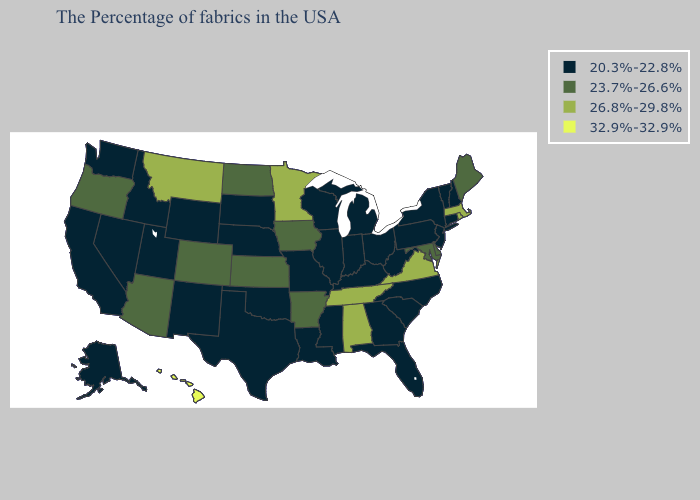What is the lowest value in the USA?
Be succinct. 20.3%-22.8%. Name the states that have a value in the range 26.8%-29.8%?
Be succinct. Massachusetts, Rhode Island, Virginia, Alabama, Tennessee, Minnesota, Montana. Among the states that border Arizona , which have the lowest value?
Quick response, please. New Mexico, Utah, Nevada, California. Among the states that border Idaho , does Montana have the highest value?
Quick response, please. Yes. Which states hav the highest value in the Northeast?
Quick response, please. Massachusetts, Rhode Island. Name the states that have a value in the range 23.7%-26.6%?
Be succinct. Maine, Delaware, Maryland, Arkansas, Iowa, Kansas, North Dakota, Colorado, Arizona, Oregon. Name the states that have a value in the range 23.7%-26.6%?
Concise answer only. Maine, Delaware, Maryland, Arkansas, Iowa, Kansas, North Dakota, Colorado, Arizona, Oregon. What is the value of Idaho?
Give a very brief answer. 20.3%-22.8%. Name the states that have a value in the range 20.3%-22.8%?
Answer briefly. New Hampshire, Vermont, Connecticut, New York, New Jersey, Pennsylvania, North Carolina, South Carolina, West Virginia, Ohio, Florida, Georgia, Michigan, Kentucky, Indiana, Wisconsin, Illinois, Mississippi, Louisiana, Missouri, Nebraska, Oklahoma, Texas, South Dakota, Wyoming, New Mexico, Utah, Idaho, Nevada, California, Washington, Alaska. What is the value of New York?
Give a very brief answer. 20.3%-22.8%. Name the states that have a value in the range 32.9%-32.9%?
Keep it brief. Hawaii. Is the legend a continuous bar?
Answer briefly. No. What is the value of Maine?
Short answer required. 23.7%-26.6%. 